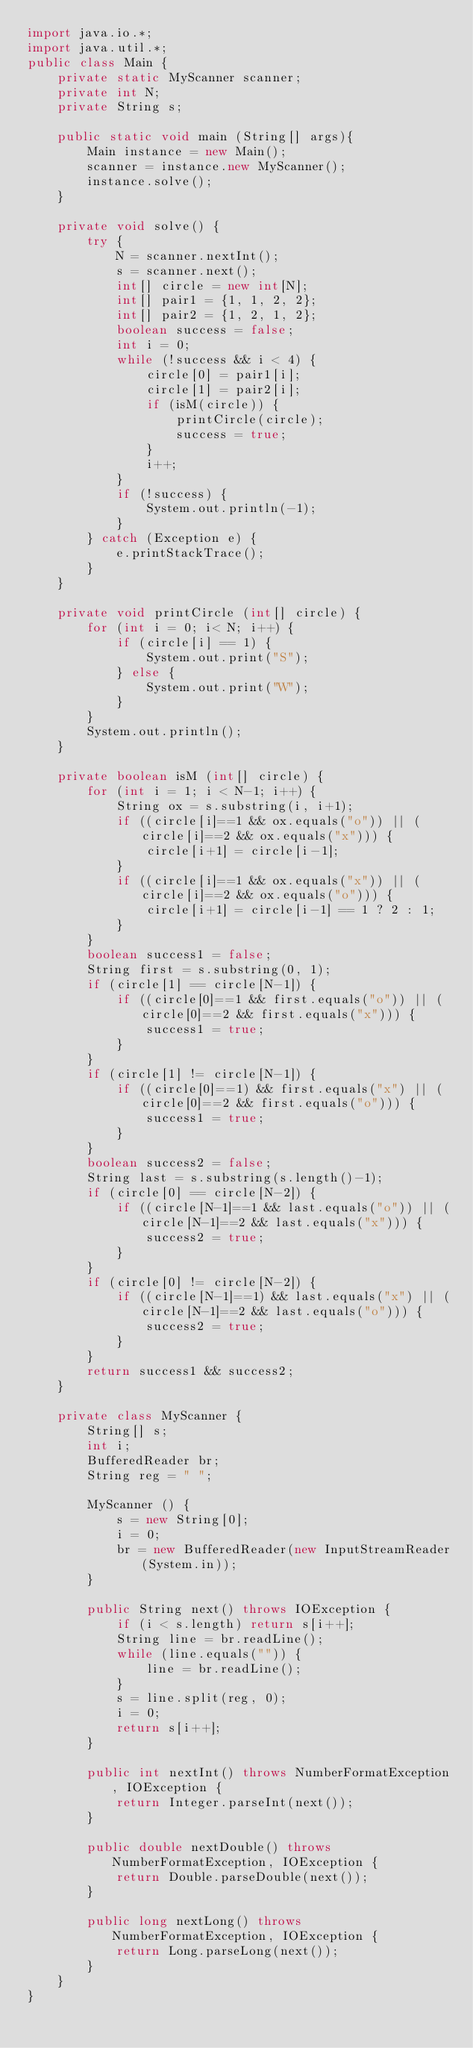Convert code to text. <code><loc_0><loc_0><loc_500><loc_500><_Java_>import java.io.*;
import java.util.*;
public class Main {
    private static MyScanner scanner;
    private int N;
    private String s;

    public static void main (String[] args){
        Main instance = new Main();
        scanner = instance.new MyScanner();
        instance.solve();
    }

    private void solve() {
        try {
            N = scanner.nextInt();
            s = scanner.next();
            int[] circle = new int[N];
            int[] pair1 = {1, 1, 2, 2};
            int[] pair2 = {1, 2, 1, 2};
            boolean success = false;
            int i = 0;
            while (!success && i < 4) {
                circle[0] = pair1[i];
                circle[1] = pair2[i];
                if (isM(circle)) {
                    printCircle(circle);
                    success = true;
                }
                i++;
            }
            if (!success) {
                System.out.println(-1);
            }
        } catch (Exception e) {
            e.printStackTrace();
        }
    }

    private void printCircle (int[] circle) {
        for (int i = 0; i< N; i++) {
            if (circle[i] == 1) {
                System.out.print("S");
            } else {
                System.out.print("W");
            }
        }
        System.out.println();
    }

    private boolean isM (int[] circle) {
        for (int i = 1; i < N-1; i++) {
            String ox = s.substring(i, i+1);
            if ((circle[i]==1 && ox.equals("o")) || (circle[i]==2 && ox.equals("x"))) {
                circle[i+1] = circle[i-1];
            }
            if ((circle[i]==1 && ox.equals("x")) || (circle[i]==2 && ox.equals("o"))) {
                circle[i+1] = circle[i-1] == 1 ? 2 : 1;
            }
        }
        boolean success1 = false;
        String first = s.substring(0, 1);
        if (circle[1] == circle[N-1]) {
            if ((circle[0]==1 && first.equals("o")) || (circle[0]==2 && first.equals("x"))) {
                success1 = true;
            }
        }
        if (circle[1] != circle[N-1]) {
            if ((circle[0]==1) && first.equals("x") || (circle[0]==2 && first.equals("o"))) {
                success1 = true;
            }
        }
        boolean success2 = false;
        String last = s.substring(s.length()-1);
        if (circle[0] == circle[N-2]) {
            if ((circle[N-1]==1 && last.equals("o")) || (circle[N-1]==2 && last.equals("x"))) {
                success2 = true;
            }
        }
        if (circle[0] != circle[N-2]) {
            if ((circle[N-1]==1) && last.equals("x") || (circle[N-1]==2 && last.equals("o"))) {
                success2 = true;
            }
        }
        return success1 && success2;
    }

    private class MyScanner {
        String[] s;
        int i;
        BufferedReader br;
        String reg = " ";

        MyScanner () {
            s = new String[0];
            i = 0;
            br = new BufferedReader(new InputStreamReader(System.in));
        }

        public String next() throws IOException {
            if (i < s.length) return s[i++];
            String line = br.readLine();
            while (line.equals("")) {
                line = br.readLine();
            }
            s = line.split(reg, 0);
            i = 0;
            return s[i++];
        }

        public int nextInt() throws NumberFormatException, IOException {
            return Integer.parseInt(next());
        }

        public double nextDouble() throws NumberFormatException, IOException {
            return Double.parseDouble(next());
        }

        public long nextLong() throws NumberFormatException, IOException {
            return Long.parseLong(next());
        }
    }
}</code> 